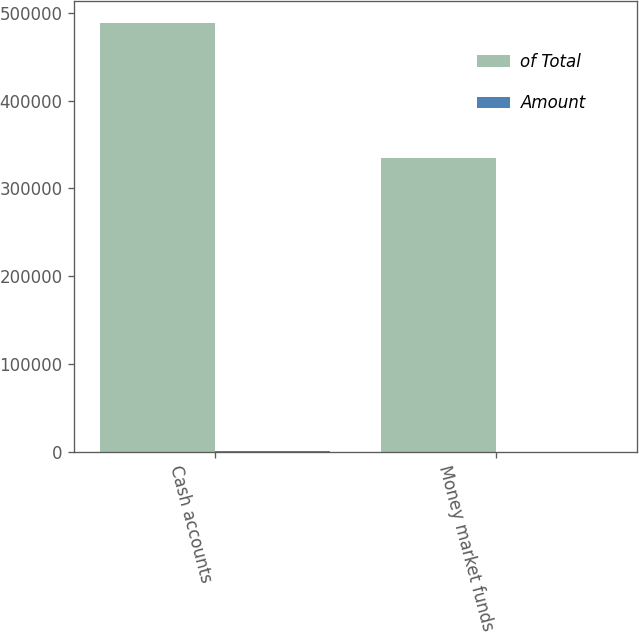Convert chart to OTSL. <chart><loc_0><loc_0><loc_500><loc_500><stacked_bar_chart><ecel><fcel>Cash accounts<fcel>Money market funds<nl><fcel>of Total<fcel>488504<fcel>333975<nl><fcel>Amount<fcel>59.4<fcel>40.6<nl></chart> 